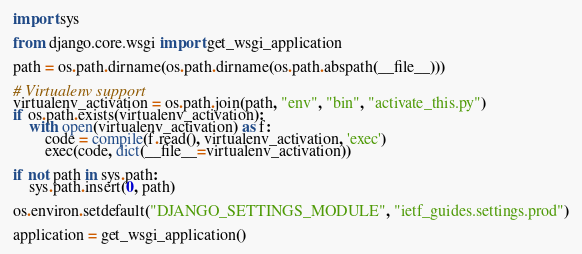Convert code to text. <code><loc_0><loc_0><loc_500><loc_500><_Python_>import sys

from django.core.wsgi import get_wsgi_application

path = os.path.dirname(os.path.dirname(os.path.abspath(__file__)))

# Virtualenv support
virtualenv_activation = os.path.join(path, "env", "bin", "activate_this.py")
if os.path.exists(virtualenv_activation):
    with open(virtualenv_activation) as f:
        code = compile(f.read(), virtualenv_activation, 'exec')
        exec(code, dict(__file__=virtualenv_activation))

if not path in sys.path:
    sys.path.insert(0, path)

os.environ.setdefault("DJANGO_SETTINGS_MODULE", "ietf_guides.settings.prod")

application = get_wsgi_application()
</code> 